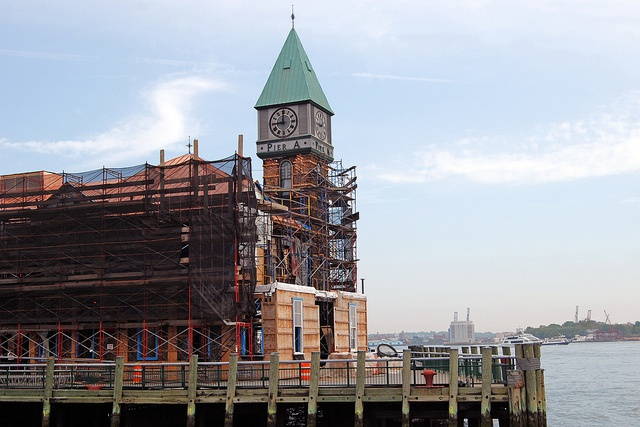Describe the objects in this image and their specific colors. I can see clock in lavender, gray, black, and darkgray tones, clock in lavender, darkgray, and gray tones, boat in lavender, darkgray, lightgray, gray, and navy tones, and boat in lavender, darkgray, lightgray, navy, and gray tones in this image. 